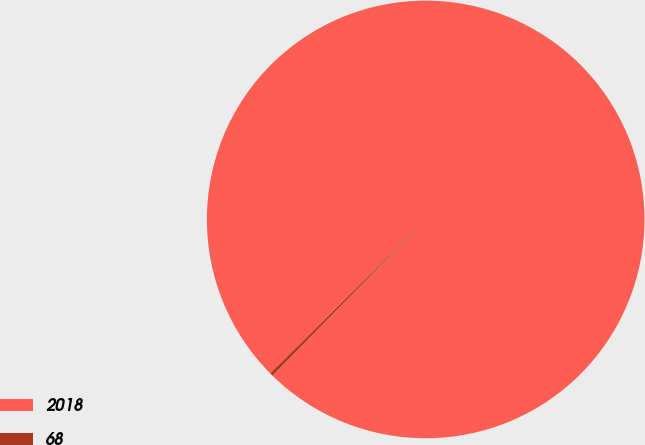Convert chart. <chart><loc_0><loc_0><loc_500><loc_500><pie_chart><fcel>2018<fcel>68<nl><fcel>99.77%<fcel>0.23%<nl></chart> 